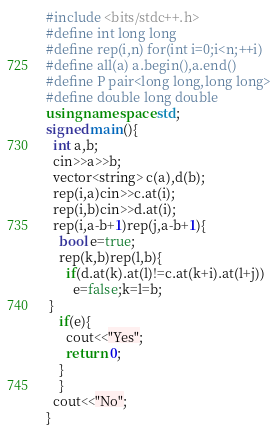<code> <loc_0><loc_0><loc_500><loc_500><_C++_>#include <bits/stdc++.h>
#define int long long
#define rep(i,n) for(int i=0;i<n;++i)
#define all(a) a.begin(),a.end()
#define P pair<long long,long long>
#define double long double
using namespace std;
signed main(){
  int a,b;
  cin>>a>>b;
  vector<string> c(a),d(b);
  rep(i,a)cin>>c.at(i);
  rep(i,b)cin>>d.at(i);
  rep(i,a-b+1)rep(j,a-b+1){
    bool e=true;
    rep(k,b)rep(l,b){
      if(d.at(k).at(l)!=c.at(k+i).at(l+j))
        e=false;k=l=b;
 }
    if(e){
      cout<<"Yes";
      return 0;
    }
    }
  cout<<"No";
}</code> 